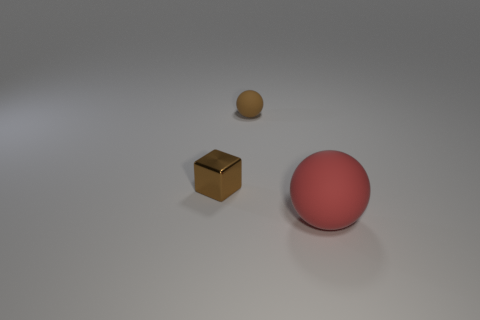How would you describe the lighting and mood of this scene? The lighting in the image is soft and diffused, casting gentle shadows that suggest an overcast or studio-lit setting. The mood is neutral and calm, with a minimalist aesthetic that doesn't convey a specific emotion but rather creates a serene and uncluttered visual space. 